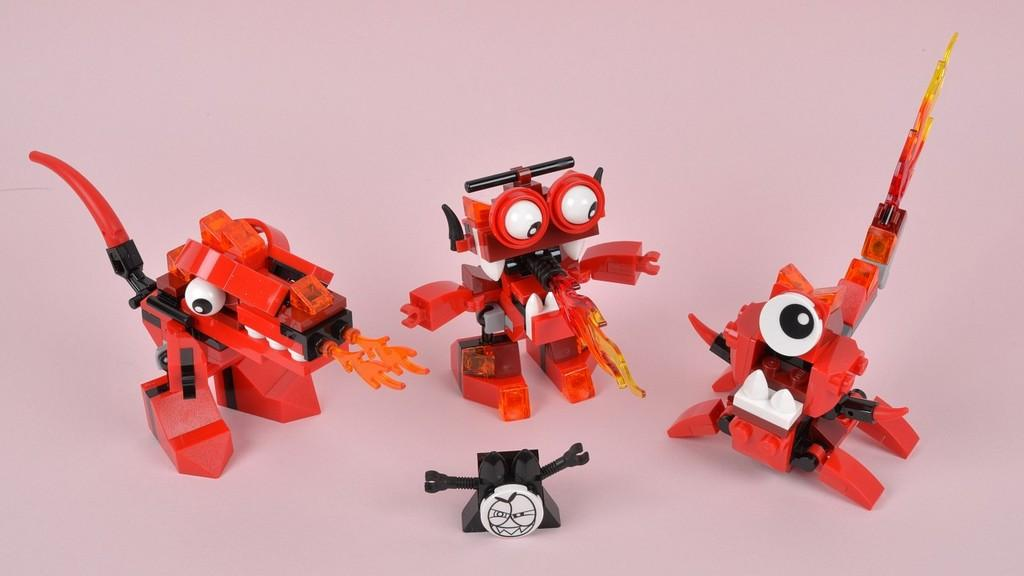What color are the toys in the image? The toys in the image are red. Can you describe the object at the bottom of the image? There is a black color object at the bottom of the image. What advice does the woman in the image give to the cattle? There is no woman or cattle present in the image. 